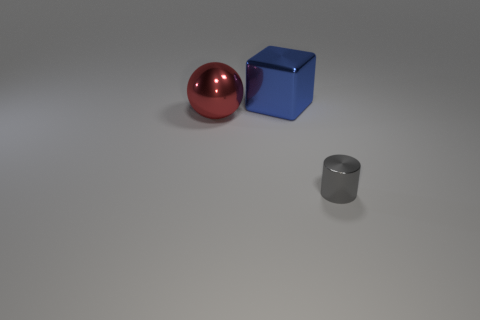What number of large yellow cylinders are there?
Make the answer very short. 0. Are there any big yellow blocks that have the same material as the sphere?
Ensure brevity in your answer.  No. There is a thing that is behind the sphere; is it the same size as the thing that is in front of the ball?
Your answer should be compact. No. There is a metal object that is behind the red metallic sphere; what is its size?
Keep it short and to the point. Large. Are there any large metal balls behind the tiny gray cylinder right of the big red metal ball?
Make the answer very short. Yes. Does the red metallic ball have the same size as the blue shiny object on the right side of the big metallic ball?
Offer a very short reply. Yes. Is there a blue thing that is behind the metal object to the left of the shiny object behind the large red metal sphere?
Offer a terse response. Yes. There is a thing behind the big red ball; what material is it?
Give a very brief answer. Metal. Do the red metallic thing and the blue thing have the same size?
Give a very brief answer. Yes. There is a thing that is to the left of the small gray object and on the right side of the red sphere; what is its color?
Make the answer very short. Blue. 